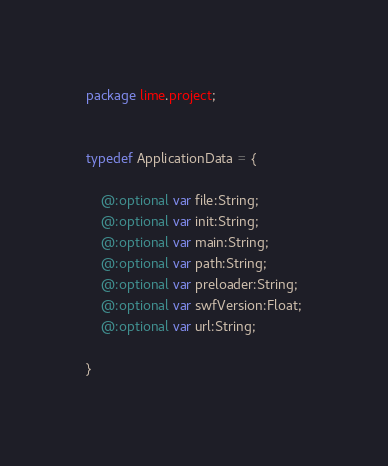<code> <loc_0><loc_0><loc_500><loc_500><_Haxe_>package lime.project;


typedef ApplicationData = {
	
	@:optional var file:String;
	@:optional var init:String;
	@:optional var main:String;
	@:optional var path:String;
	@:optional var preloader:String;
	@:optional var swfVersion:Float;
	@:optional var url:String;
	
}</code> 